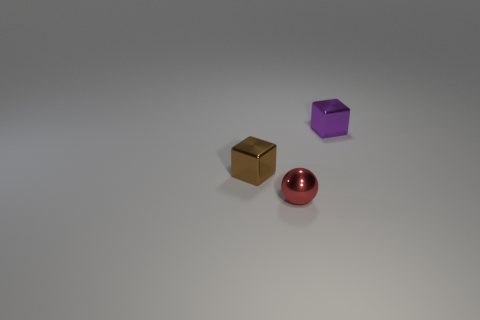Add 1 red matte cylinders. How many objects exist? 4 Subtract all balls. How many objects are left? 2 Add 2 red things. How many red things are left? 3 Add 2 small red spheres. How many small red spheres exist? 3 Subtract 0 cyan blocks. How many objects are left? 3 Subtract all red things. Subtract all balls. How many objects are left? 1 